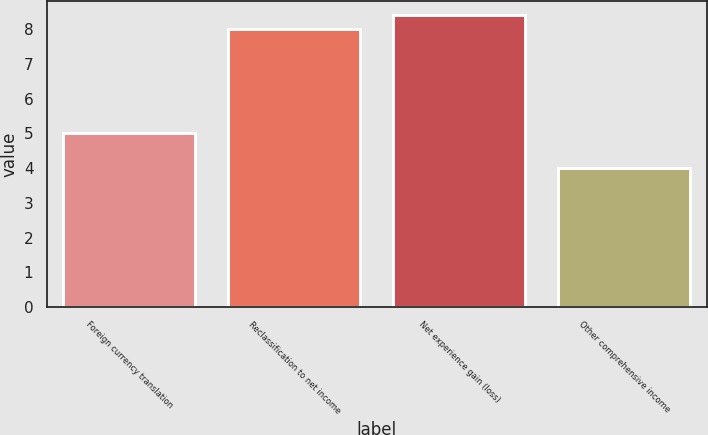Convert chart to OTSL. <chart><loc_0><loc_0><loc_500><loc_500><bar_chart><fcel>Foreign currency translation<fcel>Reclassification to net income<fcel>Net experience gain (loss)<fcel>Other comprehensive income<nl><fcel>5<fcel>8<fcel>8.4<fcel>4<nl></chart> 